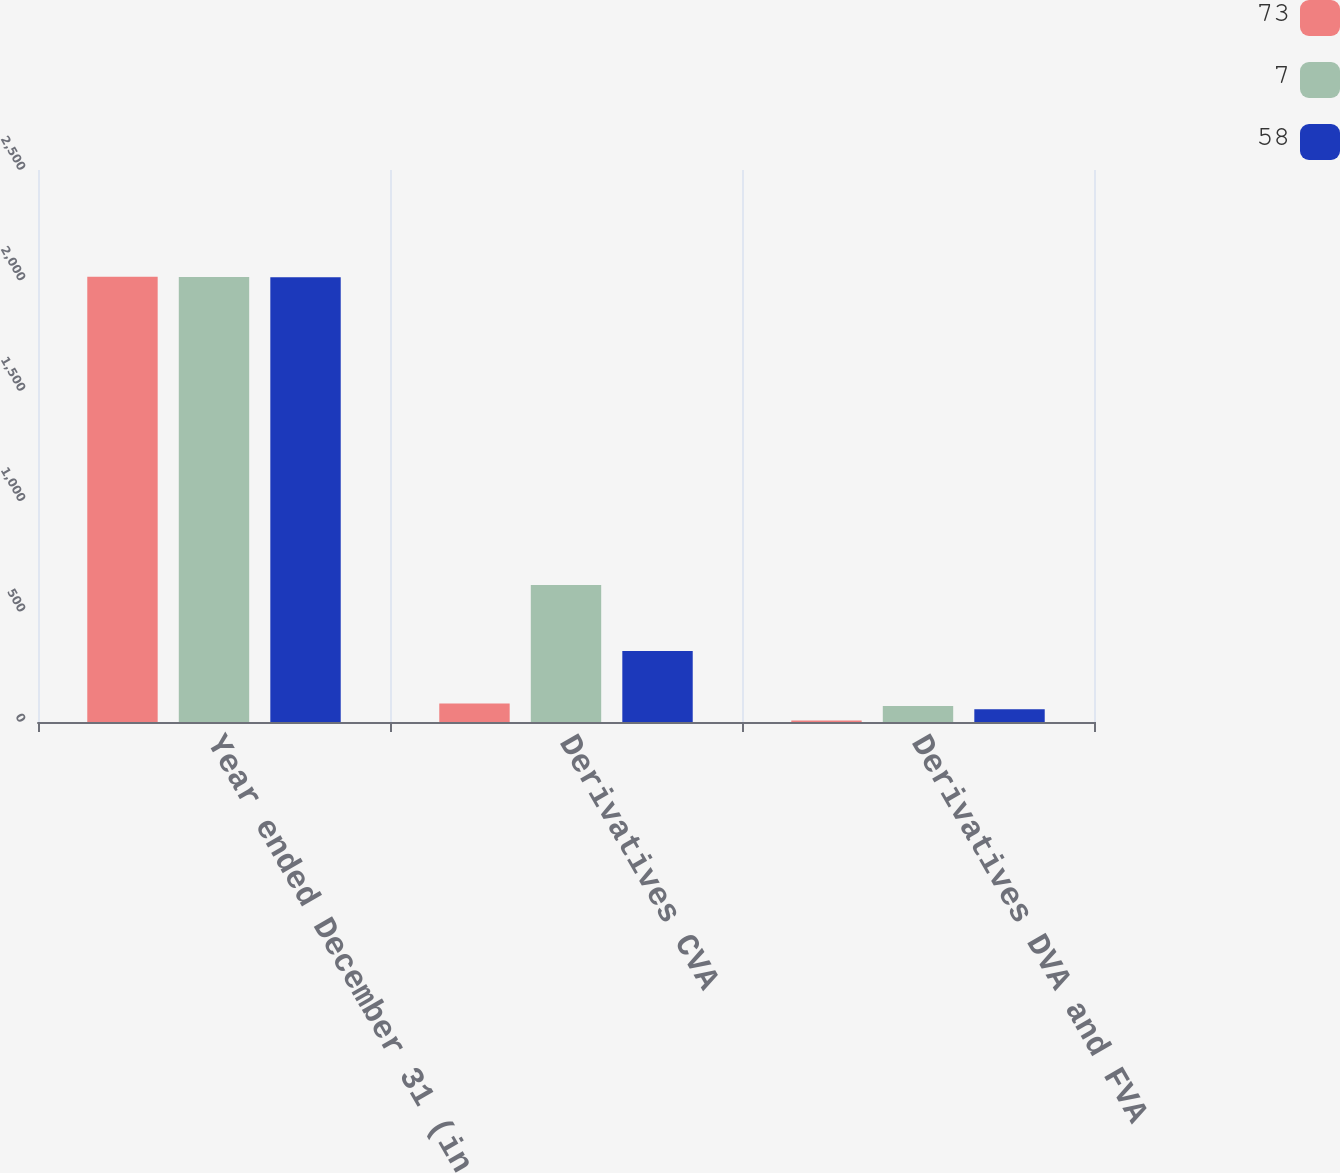<chart> <loc_0><loc_0><loc_500><loc_500><stacked_bar_chart><ecel><fcel>Year ended December 31 (in<fcel>Derivatives CVA<fcel>Derivatives DVA and FVA<nl><fcel>73<fcel>2016<fcel>84<fcel>7<nl><fcel>7<fcel>2015<fcel>620<fcel>73<nl><fcel>58<fcel>2014<fcel>322<fcel>58<nl></chart> 